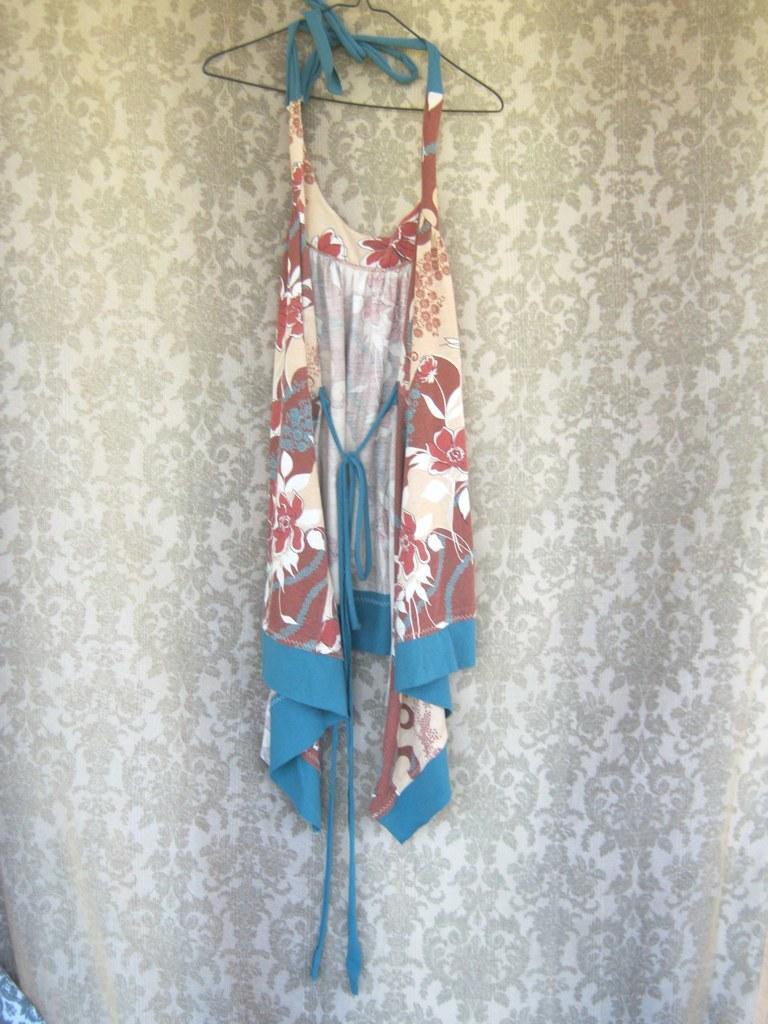Could you give a brief overview of what you see in this image? In this image we can see one curtain, one dress hanged on a hanger and one object on the surface. 